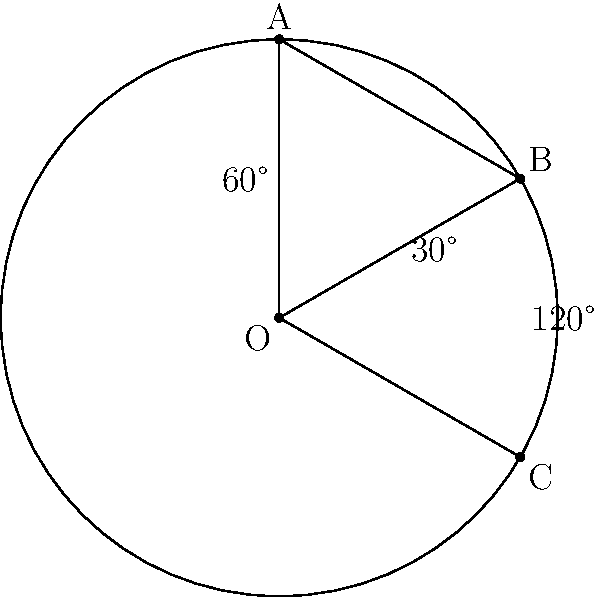In a cricket field, three fielders are positioned as shown in the diagram. Fielder A is at long-on, B is at deep extra cover, and C is at deep point. If the angle between A and B is 60°, and the angle between B and C is 120°, what is the angle between A and C? Let's approach this step-by-step:

1) In a circle, the sum of angles in a complete rotation is 360°.

2) We are given two angles:
   - Angle AOB = 60°
   - Angle BOC = 120°

3) Let's call the angle we're looking for (between A and C) as x.

4) We know that these three angles must sum to 360°:

   $$ 60° + 120° + x = 360° $$

5) Simplifying:

   $$ 180° + x = 360° $$

6) Subtracting 180° from both sides:

   $$ x = 360° - 180° = 180° $$

Therefore, the angle between A and C is 180°.
Answer: 180° 